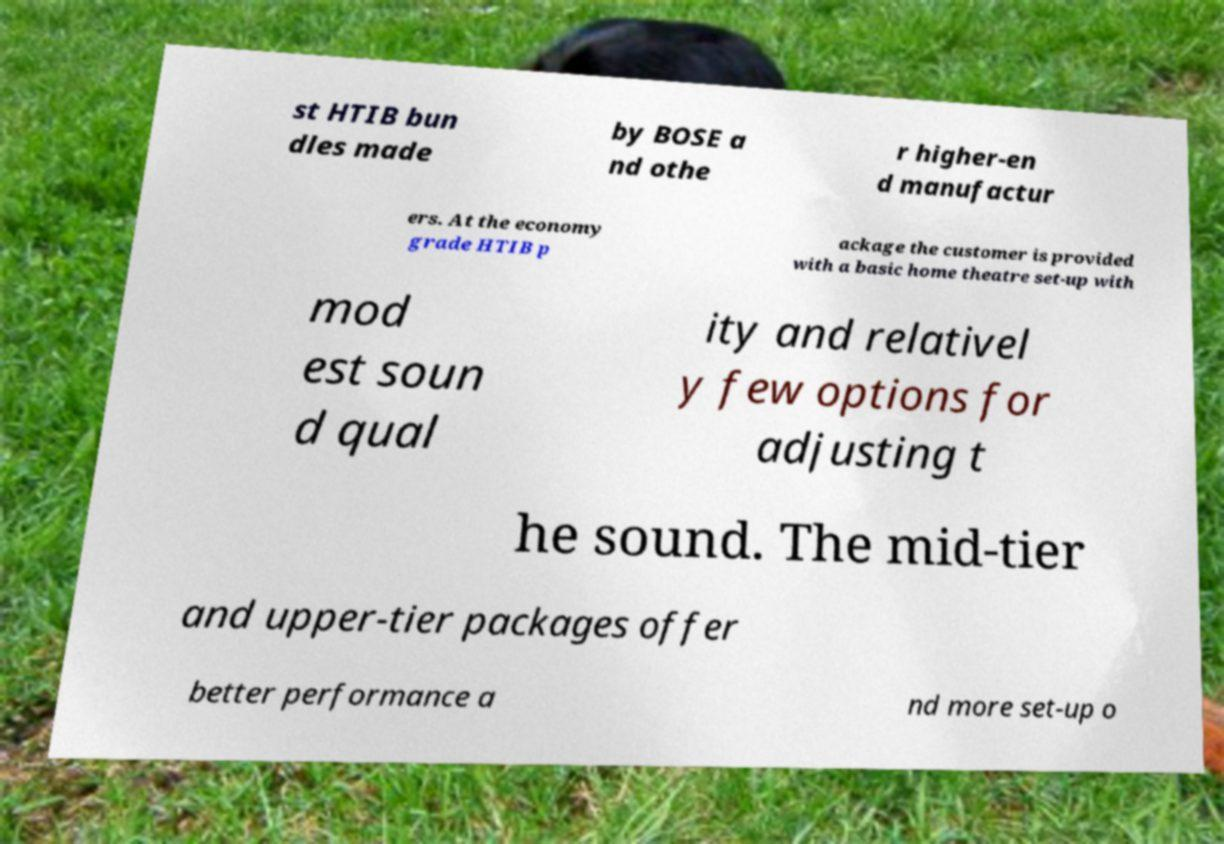Could you extract and type out the text from this image? st HTIB bun dles made by BOSE a nd othe r higher-en d manufactur ers. At the economy grade HTIB p ackage the customer is provided with a basic home theatre set-up with mod est soun d qual ity and relativel y few options for adjusting t he sound. The mid-tier and upper-tier packages offer better performance a nd more set-up o 